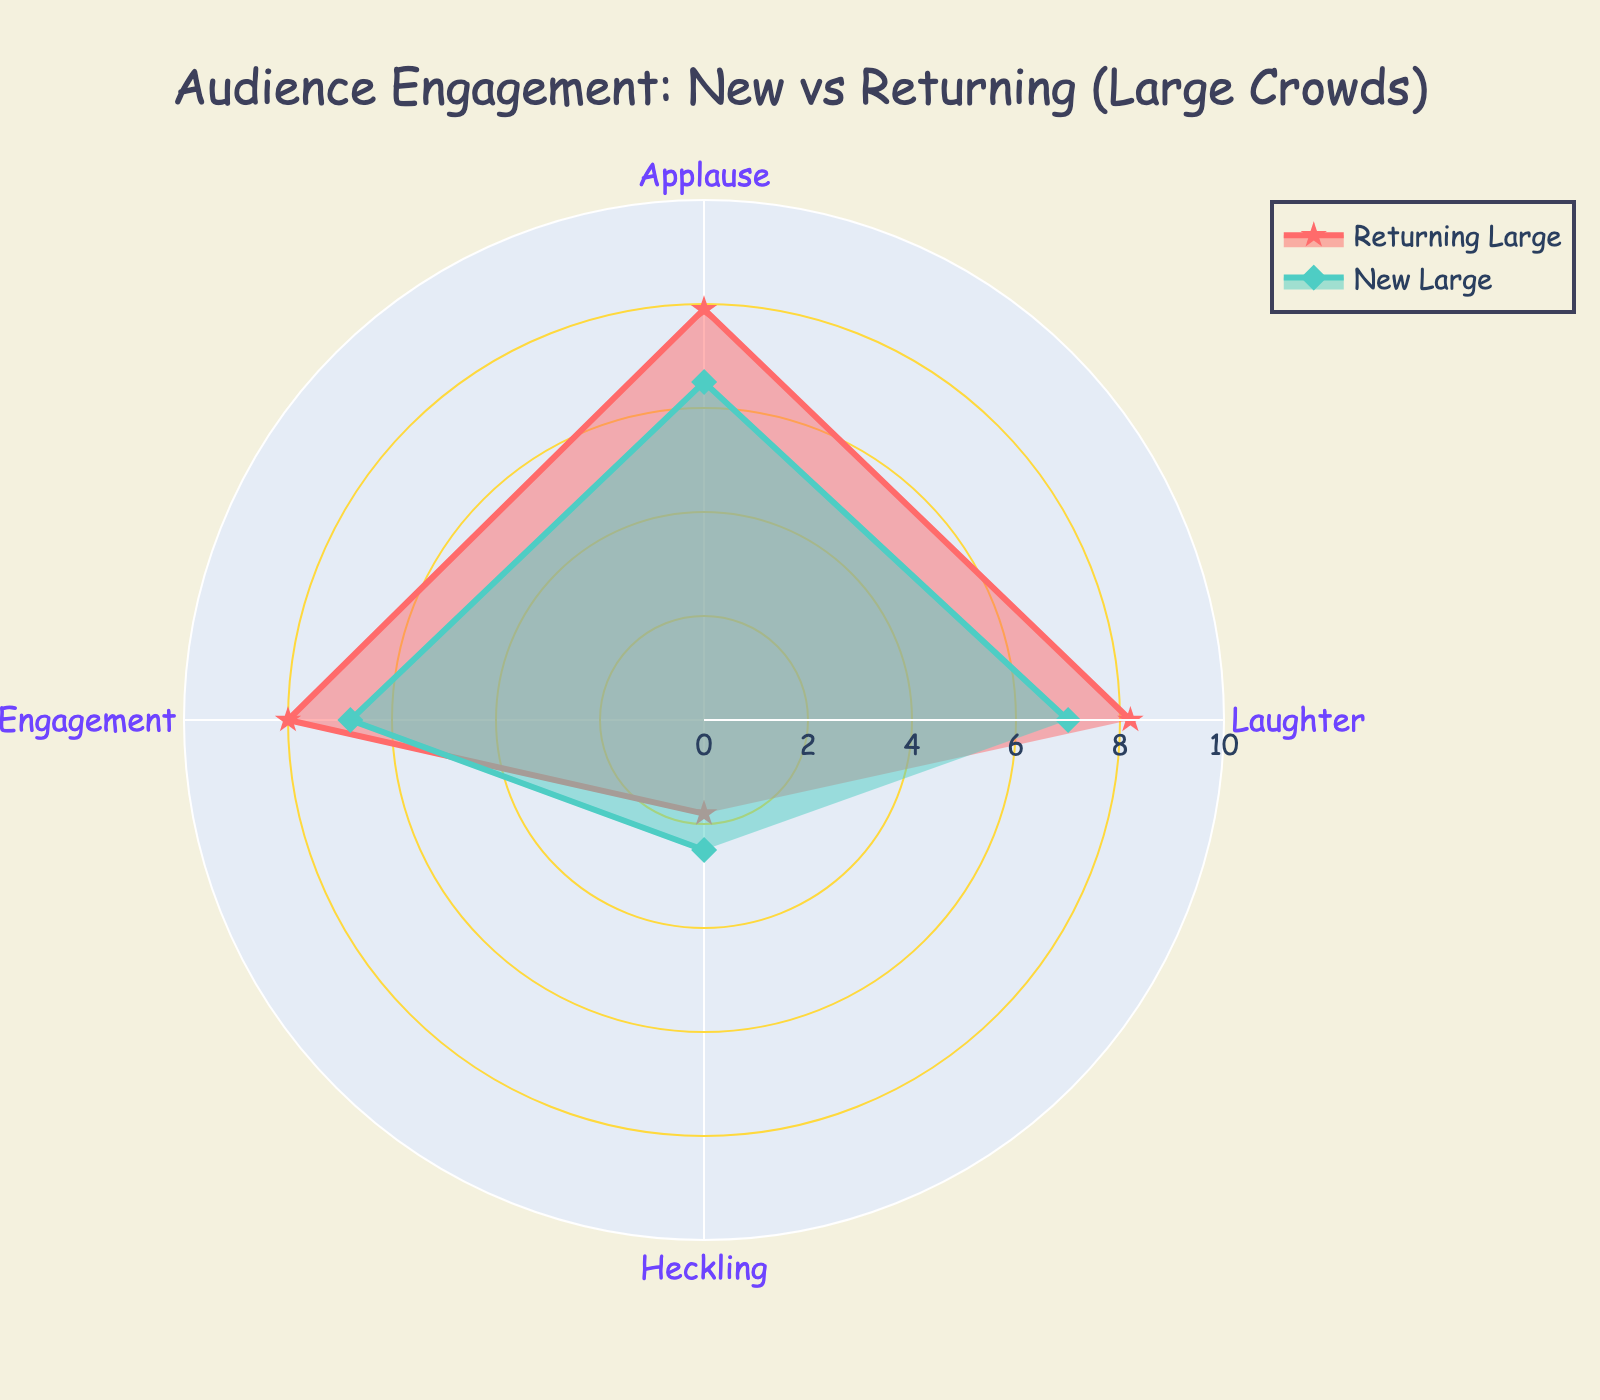What is the title of the radar chart? The title is at the top of the chart and usually provides a summary of what the chart represents.
Answer: Audience Engagement: New vs Returning (Large Crowds) What is the range of the radial axis? The radial axis range is depicted in the figure by examining the grid lines that indicate the minimum and maximum values.
Answer: 0 to 10 Which audience group has the highest laughter rate? By looking at the 'Laughter' category values in the radar chart, identify which of the four audience groups has the highest rate.
Answer: Returning Large How does heckling compare between new and returning large audiences? Check the 'Heckling' category values for both new and returning large audiences to see which is higher.
Answer: New Large (2.5 vs 1.8) Which performance category shows the smallest difference between new large and returning large audiences? Compare the values in each performance category between new large and returning large audiences and find the smallest difference.
Answer: Heckling Which engagement type has the widest disparity between new and returning large audiences? Identify the engagement type by calculating the differences in values for each engagement category and find the maximum difference.
Answer: Applause (7.9 vs 6.5 = 1.4) What is the average engagement level of returning large audiences across all performance categories? Sum the values of all performance categories for returning large audiences and then divide by the number of categories. (8.2+7.9+8.0+1.8)/4
Answer: 6.475 In which performance category do new large audiences outperform new small audiences the most? Compare the values between new large and new small audiences across all performance categories and find the category with the greatest difference.
Answer: Laughter (7.0 vs 6.0 = 1.0) What is the total engagement score for returning large audiences? Add up all the engagement scores for returning large audiences. (8.2+7.9+8.0+1.8)
Answer: 25.9 Which engagement type shows the least variability across all audience groups? Calculate the range for each engagement type across all audience groups and identify the one with the smallest range.
Answer: Heckling 